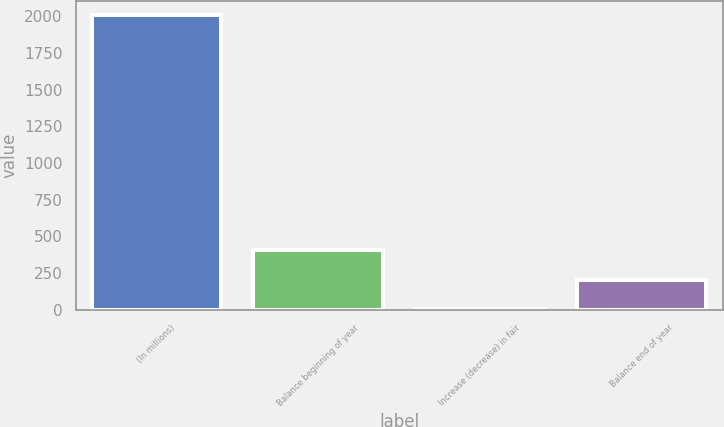Convert chart. <chart><loc_0><loc_0><loc_500><loc_500><bar_chart><fcel>(In millions)<fcel>Balance beginning of year<fcel>Increase (decrease) in fair<fcel>Balance end of year<nl><fcel>2006<fcel>405.2<fcel>5<fcel>205.1<nl></chart> 